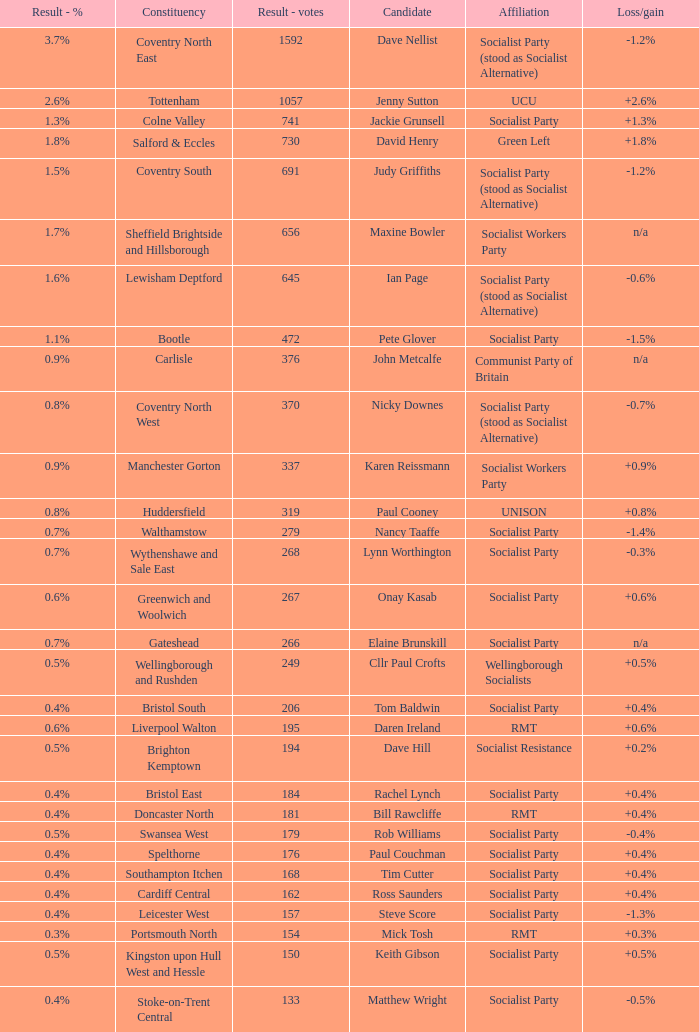What is the largest vote result if loss/gain is -0.5%? 133.0. 